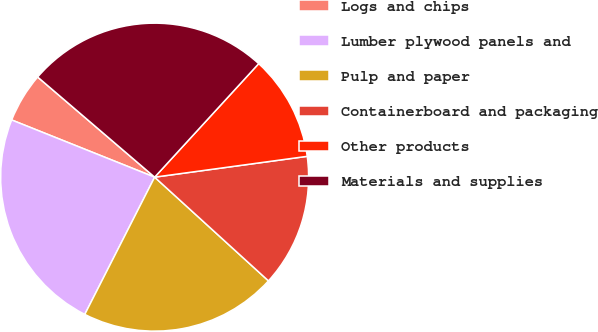Convert chart to OTSL. <chart><loc_0><loc_0><loc_500><loc_500><pie_chart><fcel>Logs and chips<fcel>Lumber plywood panels and<fcel>Pulp and paper<fcel>Containerboard and packaging<fcel>Other products<fcel>Materials and supplies<nl><fcel>5.21%<fcel>23.56%<fcel>20.73%<fcel>13.92%<fcel>11.03%<fcel>25.54%<nl></chart> 